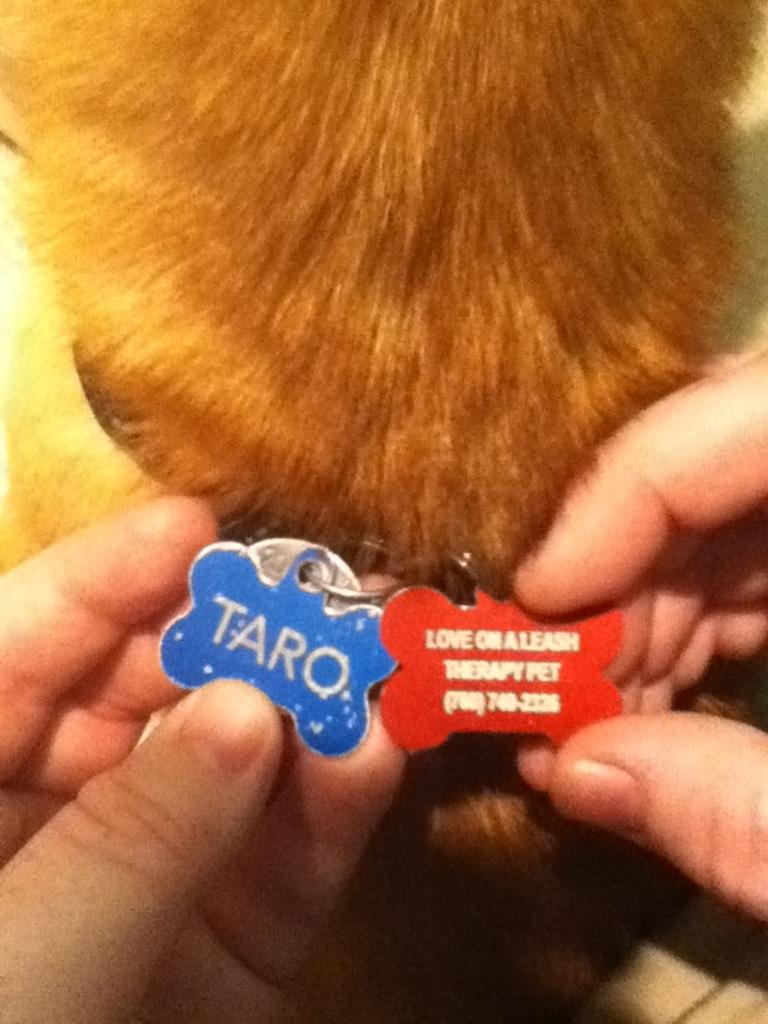Who is present in the image? There is a person in the image. What is the person holding in the image? The person is holding a locket. Can you describe the background of the image? There is an animal in the background of the image. What is the person's desire to start a van in the image? There is no mention of a van or any desire to start one in the image. 